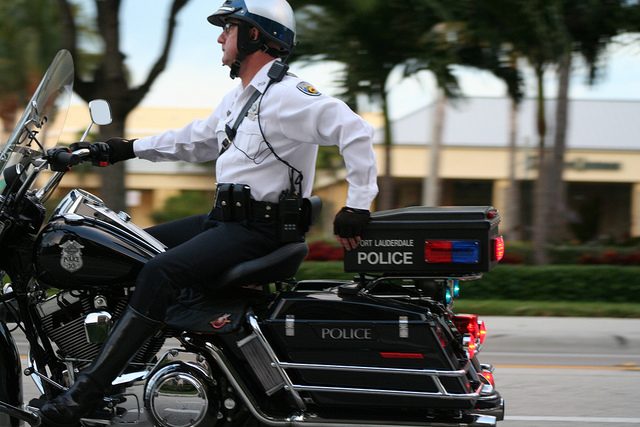Please extract the text content from this image. POLICE POLICE LAUDERDALE 